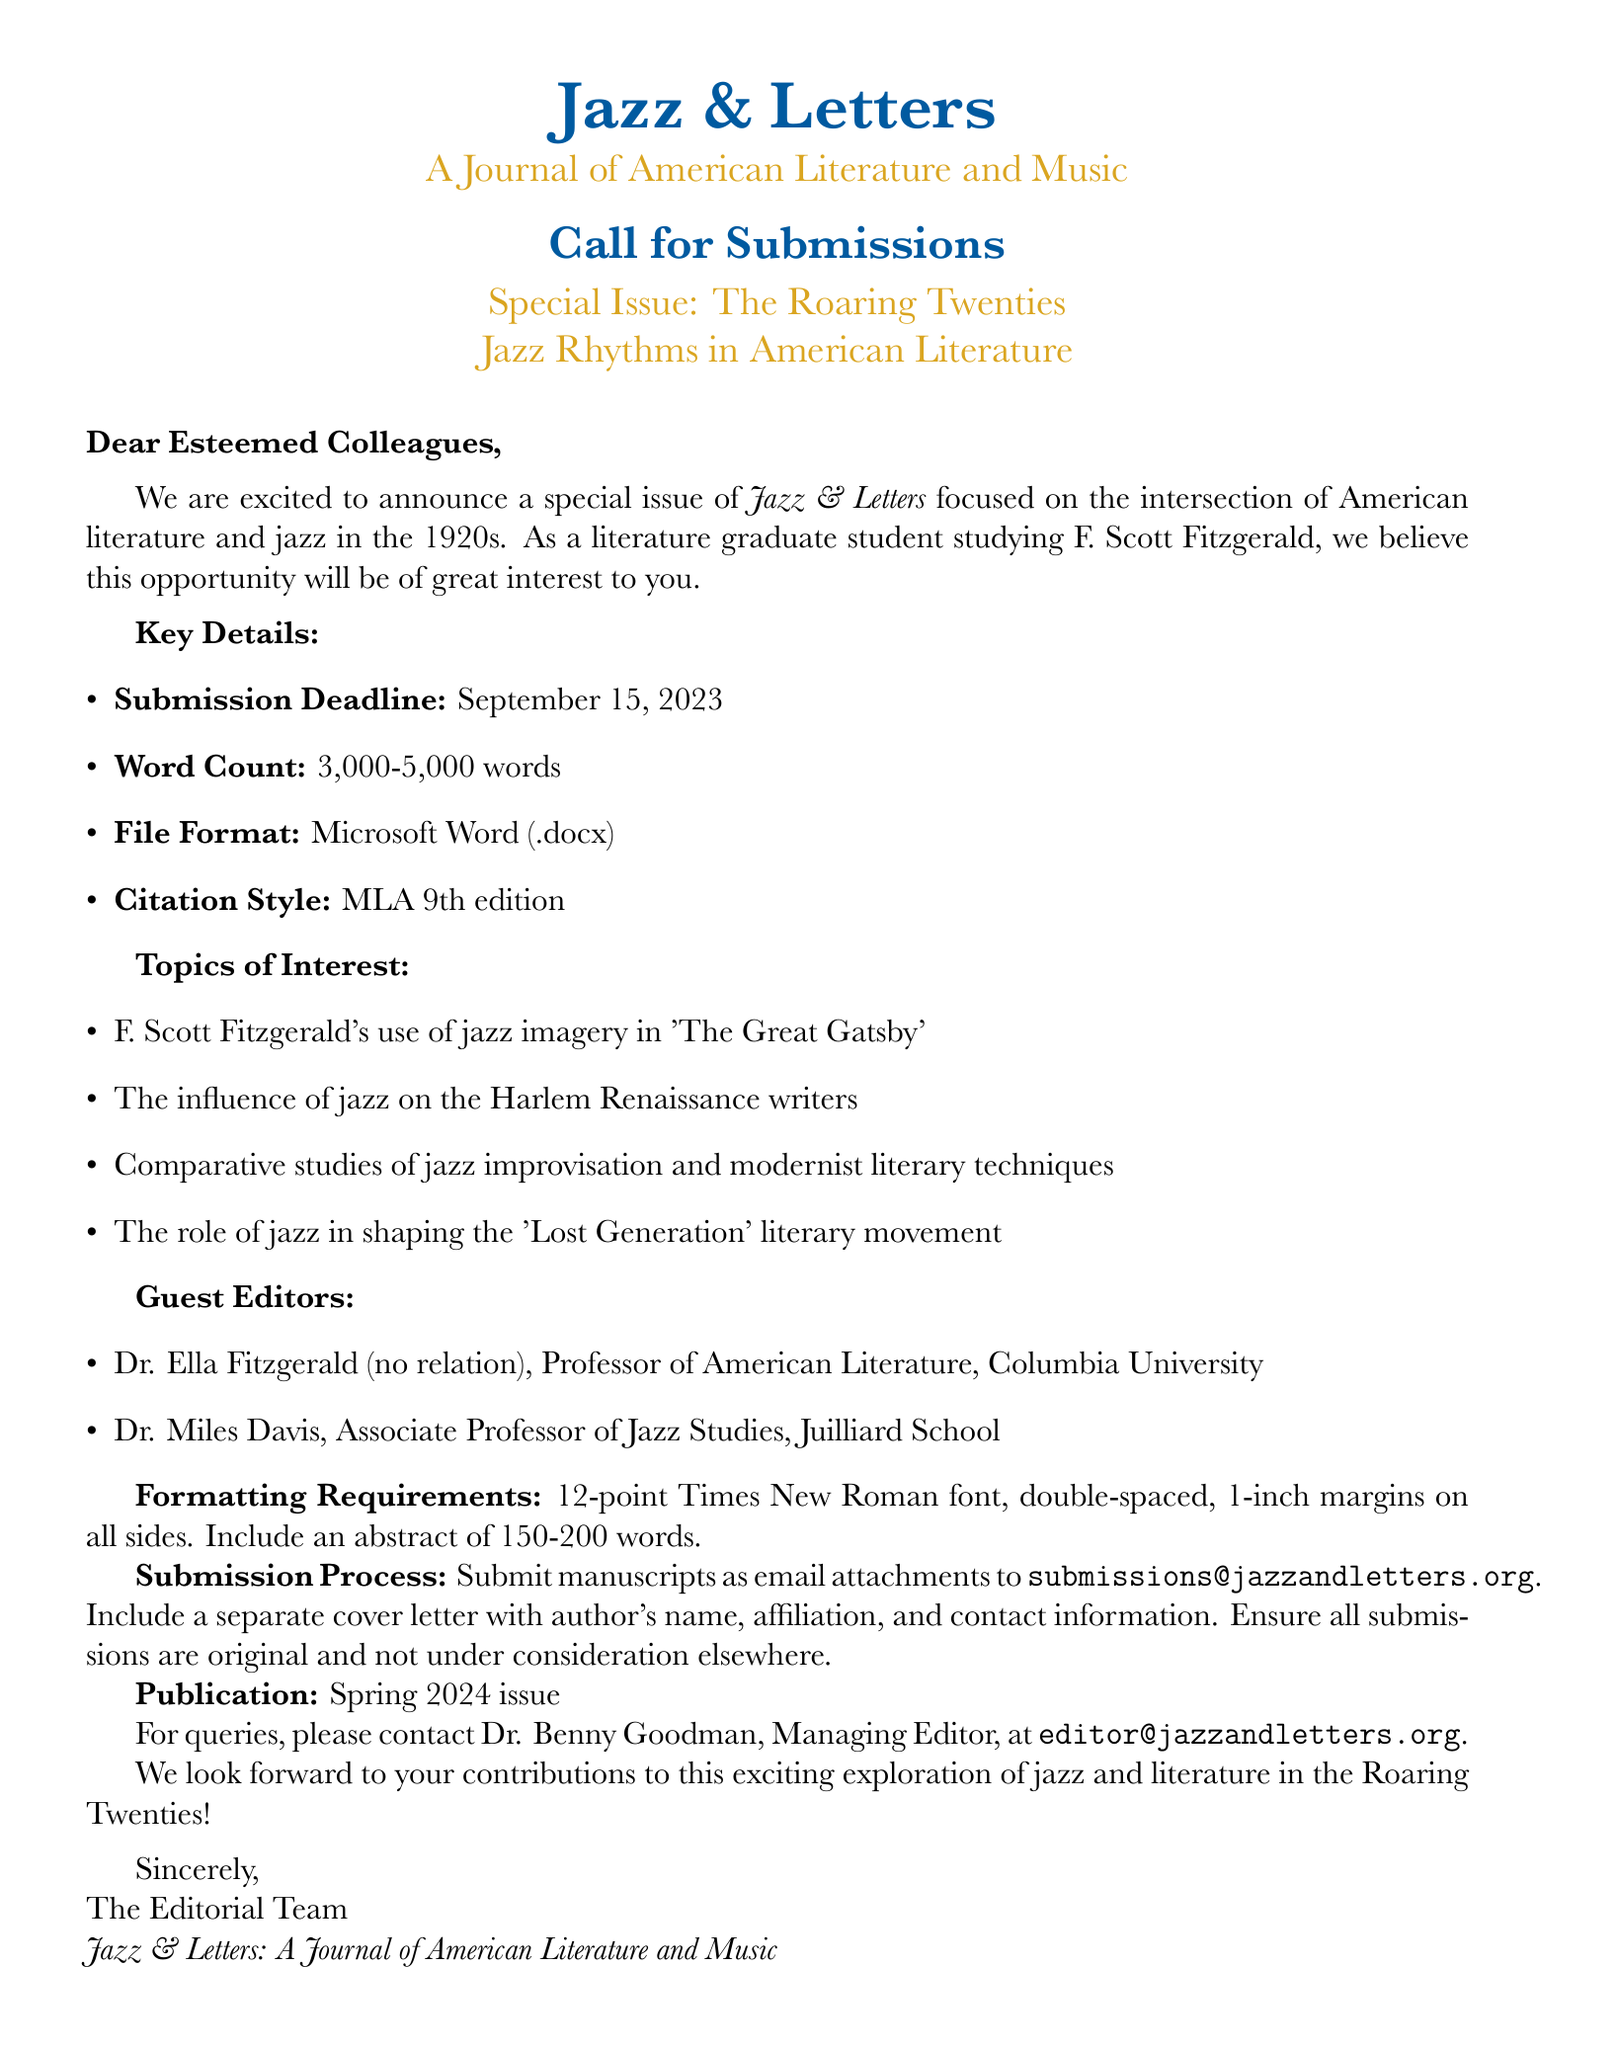What is the name of the journal? The journal is titled "Jazz & Letters: A Journal of American Literature and Music."
Answer: Jazz & Letters: A Journal of American Literature and Music Who are the guest editors for the special issue? The guest editors listed are Dr. Ella Fitzgerald and Dr. Miles Davis.
Answer: Dr. Ella Fitzgerald and Dr. Miles Davis What is the submission deadline? The submission deadline is explicitly stated as September 15, 2023.
Answer: September 15, 2023 What is the required word count range for submissions? The document specifies that the word count must be between 3,000 and 5,000 words.
Answer: 3,000-5,000 words What formatting style must citations follow? The required citation style stated in the document is MLA 9th edition.
Answer: MLA 9th edition What is the maximum length for the abstract? The document specifies that the abstract should be between 150 and 200 words long.
Answer: 150-200 words Where should submissions be sent? The email address for submission is provided as submissions@jazzandletters.org.
Answer: submissions@jazzandletters.org What is one of the topics of interest mentioned? One topic listed is the influence of jazz on the Harlem Renaissance writers.
Answer: The influence of jazz on the Harlem Renaissance writers Who should queries be directed to? Queries should be directed to Dr. Benny Goodman, as mentioned in the document.
Answer: Dr. Benny Goodman 